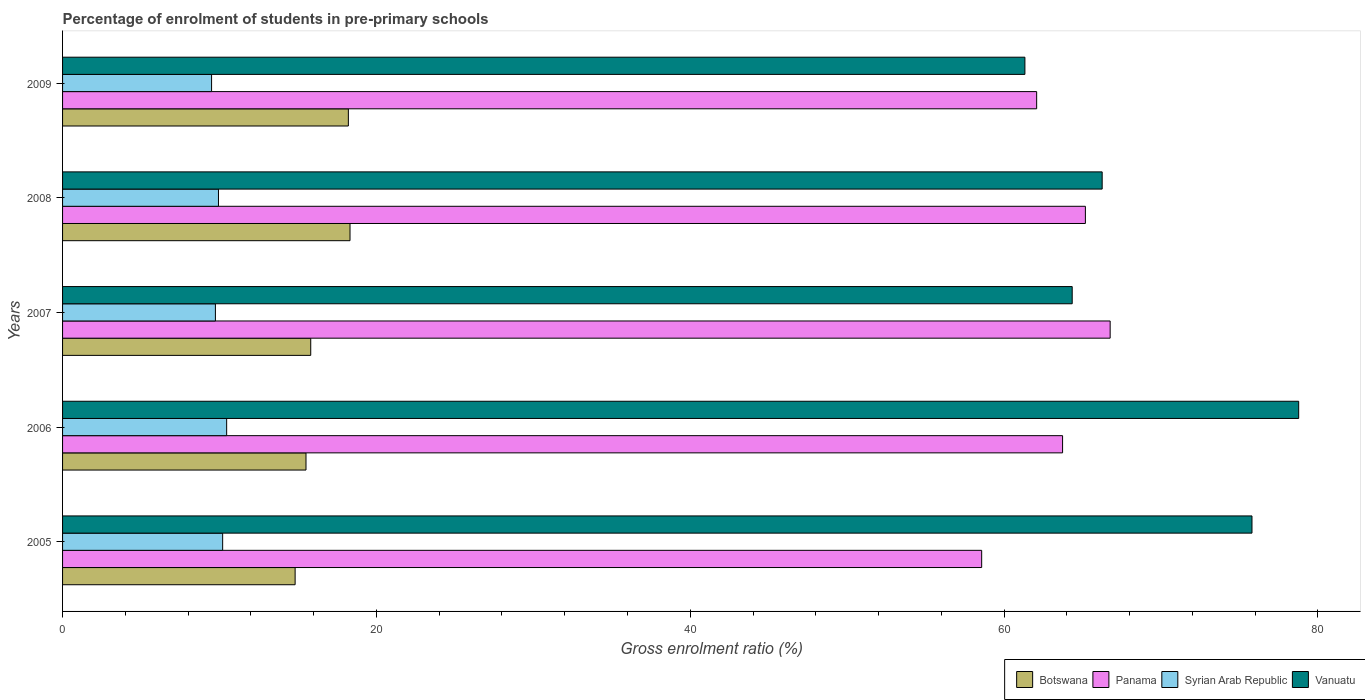How many groups of bars are there?
Make the answer very short. 5. Are the number of bars per tick equal to the number of legend labels?
Provide a succinct answer. Yes. In how many cases, is the number of bars for a given year not equal to the number of legend labels?
Provide a succinct answer. 0. What is the percentage of students enrolled in pre-primary schools in Botswana in 2009?
Offer a very short reply. 18.21. Across all years, what is the maximum percentage of students enrolled in pre-primary schools in Vanuatu?
Ensure brevity in your answer.  78.77. Across all years, what is the minimum percentage of students enrolled in pre-primary schools in Vanuatu?
Your response must be concise. 61.32. In which year was the percentage of students enrolled in pre-primary schools in Panama maximum?
Make the answer very short. 2007. In which year was the percentage of students enrolled in pre-primary schools in Syrian Arab Republic minimum?
Provide a succinct answer. 2009. What is the total percentage of students enrolled in pre-primary schools in Panama in the graph?
Make the answer very short. 316.31. What is the difference between the percentage of students enrolled in pre-primary schools in Botswana in 2007 and that in 2009?
Ensure brevity in your answer.  -2.4. What is the difference between the percentage of students enrolled in pre-primary schools in Botswana in 2005 and the percentage of students enrolled in pre-primary schools in Syrian Arab Republic in 2007?
Provide a short and direct response. 5.08. What is the average percentage of students enrolled in pre-primary schools in Botswana per year?
Ensure brevity in your answer.  16.54. In the year 2006, what is the difference between the percentage of students enrolled in pre-primary schools in Panama and percentage of students enrolled in pre-primary schools in Syrian Arab Republic?
Keep it short and to the point. 53.27. What is the ratio of the percentage of students enrolled in pre-primary schools in Syrian Arab Republic in 2005 to that in 2008?
Your answer should be very brief. 1.03. Is the percentage of students enrolled in pre-primary schools in Panama in 2005 less than that in 2006?
Your answer should be compact. Yes. What is the difference between the highest and the second highest percentage of students enrolled in pre-primary schools in Panama?
Your answer should be compact. 1.58. What is the difference between the highest and the lowest percentage of students enrolled in pre-primary schools in Panama?
Ensure brevity in your answer.  8.19. Is the sum of the percentage of students enrolled in pre-primary schools in Botswana in 2005 and 2008 greater than the maximum percentage of students enrolled in pre-primary schools in Panama across all years?
Offer a very short reply. No. What does the 3rd bar from the top in 2007 represents?
Your response must be concise. Panama. What does the 2nd bar from the bottom in 2009 represents?
Make the answer very short. Panama. Is it the case that in every year, the sum of the percentage of students enrolled in pre-primary schools in Botswana and percentage of students enrolled in pre-primary schools in Vanuatu is greater than the percentage of students enrolled in pre-primary schools in Panama?
Your answer should be very brief. Yes. How many bars are there?
Your response must be concise. 20. Where does the legend appear in the graph?
Provide a succinct answer. Bottom right. What is the title of the graph?
Keep it short and to the point. Percentage of enrolment of students in pre-primary schools. What is the label or title of the X-axis?
Your answer should be very brief. Gross enrolment ratio (%). What is the Gross enrolment ratio (%) of Botswana in 2005?
Ensure brevity in your answer.  14.82. What is the Gross enrolment ratio (%) in Panama in 2005?
Give a very brief answer. 58.57. What is the Gross enrolment ratio (%) in Syrian Arab Republic in 2005?
Offer a very short reply. 10.2. What is the Gross enrolment ratio (%) in Vanuatu in 2005?
Your answer should be compact. 75.8. What is the Gross enrolment ratio (%) of Botswana in 2006?
Your answer should be compact. 15.51. What is the Gross enrolment ratio (%) of Panama in 2006?
Offer a very short reply. 63.73. What is the Gross enrolment ratio (%) of Syrian Arab Republic in 2006?
Provide a short and direct response. 10.46. What is the Gross enrolment ratio (%) in Vanuatu in 2006?
Provide a short and direct response. 78.77. What is the Gross enrolment ratio (%) of Botswana in 2007?
Provide a succinct answer. 15.81. What is the Gross enrolment ratio (%) in Panama in 2007?
Your answer should be compact. 66.76. What is the Gross enrolment ratio (%) in Syrian Arab Republic in 2007?
Give a very brief answer. 9.74. What is the Gross enrolment ratio (%) of Vanuatu in 2007?
Make the answer very short. 64.34. What is the Gross enrolment ratio (%) of Botswana in 2008?
Keep it short and to the point. 18.32. What is the Gross enrolment ratio (%) in Panama in 2008?
Your response must be concise. 65.18. What is the Gross enrolment ratio (%) of Syrian Arab Republic in 2008?
Provide a succinct answer. 9.93. What is the Gross enrolment ratio (%) in Vanuatu in 2008?
Keep it short and to the point. 66.25. What is the Gross enrolment ratio (%) of Botswana in 2009?
Offer a terse response. 18.21. What is the Gross enrolment ratio (%) of Panama in 2009?
Provide a short and direct response. 62.07. What is the Gross enrolment ratio (%) in Syrian Arab Republic in 2009?
Keep it short and to the point. 9.5. What is the Gross enrolment ratio (%) in Vanuatu in 2009?
Provide a short and direct response. 61.32. Across all years, what is the maximum Gross enrolment ratio (%) of Botswana?
Make the answer very short. 18.32. Across all years, what is the maximum Gross enrolment ratio (%) of Panama?
Make the answer very short. 66.76. Across all years, what is the maximum Gross enrolment ratio (%) in Syrian Arab Republic?
Make the answer very short. 10.46. Across all years, what is the maximum Gross enrolment ratio (%) of Vanuatu?
Offer a very short reply. 78.77. Across all years, what is the minimum Gross enrolment ratio (%) in Botswana?
Ensure brevity in your answer.  14.82. Across all years, what is the minimum Gross enrolment ratio (%) in Panama?
Your answer should be compact. 58.57. Across all years, what is the minimum Gross enrolment ratio (%) of Syrian Arab Republic?
Keep it short and to the point. 9.5. Across all years, what is the minimum Gross enrolment ratio (%) of Vanuatu?
Ensure brevity in your answer.  61.32. What is the total Gross enrolment ratio (%) of Botswana in the graph?
Provide a short and direct response. 82.68. What is the total Gross enrolment ratio (%) in Panama in the graph?
Provide a succinct answer. 316.31. What is the total Gross enrolment ratio (%) of Syrian Arab Republic in the graph?
Offer a very short reply. 49.83. What is the total Gross enrolment ratio (%) of Vanuatu in the graph?
Ensure brevity in your answer.  346.48. What is the difference between the Gross enrolment ratio (%) of Botswana in 2005 and that in 2006?
Your answer should be very brief. -0.69. What is the difference between the Gross enrolment ratio (%) in Panama in 2005 and that in 2006?
Ensure brevity in your answer.  -5.16. What is the difference between the Gross enrolment ratio (%) in Syrian Arab Republic in 2005 and that in 2006?
Ensure brevity in your answer.  -0.26. What is the difference between the Gross enrolment ratio (%) in Vanuatu in 2005 and that in 2006?
Keep it short and to the point. -2.98. What is the difference between the Gross enrolment ratio (%) in Botswana in 2005 and that in 2007?
Provide a short and direct response. -0.99. What is the difference between the Gross enrolment ratio (%) of Panama in 2005 and that in 2007?
Offer a very short reply. -8.19. What is the difference between the Gross enrolment ratio (%) in Syrian Arab Republic in 2005 and that in 2007?
Offer a terse response. 0.46. What is the difference between the Gross enrolment ratio (%) in Vanuatu in 2005 and that in 2007?
Your answer should be very brief. 11.46. What is the difference between the Gross enrolment ratio (%) of Botswana in 2005 and that in 2008?
Ensure brevity in your answer.  -3.5. What is the difference between the Gross enrolment ratio (%) of Panama in 2005 and that in 2008?
Offer a terse response. -6.61. What is the difference between the Gross enrolment ratio (%) of Syrian Arab Republic in 2005 and that in 2008?
Make the answer very short. 0.27. What is the difference between the Gross enrolment ratio (%) in Vanuatu in 2005 and that in 2008?
Make the answer very short. 9.55. What is the difference between the Gross enrolment ratio (%) of Botswana in 2005 and that in 2009?
Give a very brief answer. -3.39. What is the difference between the Gross enrolment ratio (%) in Panama in 2005 and that in 2009?
Give a very brief answer. -3.5. What is the difference between the Gross enrolment ratio (%) in Syrian Arab Republic in 2005 and that in 2009?
Offer a very short reply. 0.71. What is the difference between the Gross enrolment ratio (%) in Vanuatu in 2005 and that in 2009?
Give a very brief answer. 14.47. What is the difference between the Gross enrolment ratio (%) in Botswana in 2006 and that in 2007?
Give a very brief answer. -0.3. What is the difference between the Gross enrolment ratio (%) in Panama in 2006 and that in 2007?
Ensure brevity in your answer.  -3.03. What is the difference between the Gross enrolment ratio (%) of Syrian Arab Republic in 2006 and that in 2007?
Give a very brief answer. 0.72. What is the difference between the Gross enrolment ratio (%) in Vanuatu in 2006 and that in 2007?
Your answer should be compact. 14.43. What is the difference between the Gross enrolment ratio (%) of Botswana in 2006 and that in 2008?
Your answer should be compact. -2.81. What is the difference between the Gross enrolment ratio (%) of Panama in 2006 and that in 2008?
Ensure brevity in your answer.  -1.45. What is the difference between the Gross enrolment ratio (%) of Syrian Arab Republic in 2006 and that in 2008?
Give a very brief answer. 0.52. What is the difference between the Gross enrolment ratio (%) in Vanuatu in 2006 and that in 2008?
Offer a very short reply. 12.52. What is the difference between the Gross enrolment ratio (%) in Botswana in 2006 and that in 2009?
Give a very brief answer. -2.7. What is the difference between the Gross enrolment ratio (%) in Panama in 2006 and that in 2009?
Provide a succinct answer. 1.65. What is the difference between the Gross enrolment ratio (%) in Syrian Arab Republic in 2006 and that in 2009?
Your answer should be compact. 0.96. What is the difference between the Gross enrolment ratio (%) of Vanuatu in 2006 and that in 2009?
Provide a short and direct response. 17.45. What is the difference between the Gross enrolment ratio (%) of Botswana in 2007 and that in 2008?
Offer a very short reply. -2.5. What is the difference between the Gross enrolment ratio (%) in Panama in 2007 and that in 2008?
Provide a short and direct response. 1.58. What is the difference between the Gross enrolment ratio (%) in Syrian Arab Republic in 2007 and that in 2008?
Keep it short and to the point. -0.19. What is the difference between the Gross enrolment ratio (%) in Vanuatu in 2007 and that in 2008?
Keep it short and to the point. -1.91. What is the difference between the Gross enrolment ratio (%) of Botswana in 2007 and that in 2009?
Offer a terse response. -2.4. What is the difference between the Gross enrolment ratio (%) of Panama in 2007 and that in 2009?
Offer a very short reply. 4.68. What is the difference between the Gross enrolment ratio (%) in Syrian Arab Republic in 2007 and that in 2009?
Offer a very short reply. 0.24. What is the difference between the Gross enrolment ratio (%) of Vanuatu in 2007 and that in 2009?
Ensure brevity in your answer.  3.01. What is the difference between the Gross enrolment ratio (%) in Botswana in 2008 and that in 2009?
Offer a very short reply. 0.11. What is the difference between the Gross enrolment ratio (%) of Panama in 2008 and that in 2009?
Offer a terse response. 3.11. What is the difference between the Gross enrolment ratio (%) of Syrian Arab Republic in 2008 and that in 2009?
Your answer should be very brief. 0.44. What is the difference between the Gross enrolment ratio (%) in Vanuatu in 2008 and that in 2009?
Ensure brevity in your answer.  4.92. What is the difference between the Gross enrolment ratio (%) in Botswana in 2005 and the Gross enrolment ratio (%) in Panama in 2006?
Provide a short and direct response. -48.91. What is the difference between the Gross enrolment ratio (%) of Botswana in 2005 and the Gross enrolment ratio (%) of Syrian Arab Republic in 2006?
Provide a short and direct response. 4.36. What is the difference between the Gross enrolment ratio (%) of Botswana in 2005 and the Gross enrolment ratio (%) of Vanuatu in 2006?
Your response must be concise. -63.95. What is the difference between the Gross enrolment ratio (%) of Panama in 2005 and the Gross enrolment ratio (%) of Syrian Arab Republic in 2006?
Your response must be concise. 48.11. What is the difference between the Gross enrolment ratio (%) of Panama in 2005 and the Gross enrolment ratio (%) of Vanuatu in 2006?
Give a very brief answer. -20.2. What is the difference between the Gross enrolment ratio (%) of Syrian Arab Republic in 2005 and the Gross enrolment ratio (%) of Vanuatu in 2006?
Make the answer very short. -68.57. What is the difference between the Gross enrolment ratio (%) of Botswana in 2005 and the Gross enrolment ratio (%) of Panama in 2007?
Make the answer very short. -51.94. What is the difference between the Gross enrolment ratio (%) of Botswana in 2005 and the Gross enrolment ratio (%) of Syrian Arab Republic in 2007?
Your answer should be compact. 5.08. What is the difference between the Gross enrolment ratio (%) in Botswana in 2005 and the Gross enrolment ratio (%) in Vanuatu in 2007?
Offer a very short reply. -49.52. What is the difference between the Gross enrolment ratio (%) of Panama in 2005 and the Gross enrolment ratio (%) of Syrian Arab Republic in 2007?
Keep it short and to the point. 48.83. What is the difference between the Gross enrolment ratio (%) in Panama in 2005 and the Gross enrolment ratio (%) in Vanuatu in 2007?
Provide a short and direct response. -5.77. What is the difference between the Gross enrolment ratio (%) in Syrian Arab Republic in 2005 and the Gross enrolment ratio (%) in Vanuatu in 2007?
Your answer should be very brief. -54.14. What is the difference between the Gross enrolment ratio (%) in Botswana in 2005 and the Gross enrolment ratio (%) in Panama in 2008?
Your answer should be very brief. -50.36. What is the difference between the Gross enrolment ratio (%) in Botswana in 2005 and the Gross enrolment ratio (%) in Syrian Arab Republic in 2008?
Your answer should be compact. 4.89. What is the difference between the Gross enrolment ratio (%) of Botswana in 2005 and the Gross enrolment ratio (%) of Vanuatu in 2008?
Your answer should be compact. -51.43. What is the difference between the Gross enrolment ratio (%) in Panama in 2005 and the Gross enrolment ratio (%) in Syrian Arab Republic in 2008?
Offer a terse response. 48.64. What is the difference between the Gross enrolment ratio (%) in Panama in 2005 and the Gross enrolment ratio (%) in Vanuatu in 2008?
Provide a succinct answer. -7.68. What is the difference between the Gross enrolment ratio (%) in Syrian Arab Republic in 2005 and the Gross enrolment ratio (%) in Vanuatu in 2008?
Ensure brevity in your answer.  -56.05. What is the difference between the Gross enrolment ratio (%) of Botswana in 2005 and the Gross enrolment ratio (%) of Panama in 2009?
Offer a very short reply. -47.25. What is the difference between the Gross enrolment ratio (%) of Botswana in 2005 and the Gross enrolment ratio (%) of Syrian Arab Republic in 2009?
Keep it short and to the point. 5.32. What is the difference between the Gross enrolment ratio (%) in Botswana in 2005 and the Gross enrolment ratio (%) in Vanuatu in 2009?
Ensure brevity in your answer.  -46.5. What is the difference between the Gross enrolment ratio (%) in Panama in 2005 and the Gross enrolment ratio (%) in Syrian Arab Republic in 2009?
Keep it short and to the point. 49.07. What is the difference between the Gross enrolment ratio (%) in Panama in 2005 and the Gross enrolment ratio (%) in Vanuatu in 2009?
Your answer should be very brief. -2.76. What is the difference between the Gross enrolment ratio (%) in Syrian Arab Republic in 2005 and the Gross enrolment ratio (%) in Vanuatu in 2009?
Keep it short and to the point. -51.12. What is the difference between the Gross enrolment ratio (%) in Botswana in 2006 and the Gross enrolment ratio (%) in Panama in 2007?
Provide a short and direct response. -51.25. What is the difference between the Gross enrolment ratio (%) of Botswana in 2006 and the Gross enrolment ratio (%) of Syrian Arab Republic in 2007?
Ensure brevity in your answer.  5.77. What is the difference between the Gross enrolment ratio (%) of Botswana in 2006 and the Gross enrolment ratio (%) of Vanuatu in 2007?
Provide a succinct answer. -48.83. What is the difference between the Gross enrolment ratio (%) of Panama in 2006 and the Gross enrolment ratio (%) of Syrian Arab Republic in 2007?
Your response must be concise. 53.99. What is the difference between the Gross enrolment ratio (%) of Panama in 2006 and the Gross enrolment ratio (%) of Vanuatu in 2007?
Provide a short and direct response. -0.61. What is the difference between the Gross enrolment ratio (%) of Syrian Arab Republic in 2006 and the Gross enrolment ratio (%) of Vanuatu in 2007?
Your answer should be very brief. -53.88. What is the difference between the Gross enrolment ratio (%) of Botswana in 2006 and the Gross enrolment ratio (%) of Panama in 2008?
Keep it short and to the point. -49.67. What is the difference between the Gross enrolment ratio (%) in Botswana in 2006 and the Gross enrolment ratio (%) in Syrian Arab Republic in 2008?
Provide a short and direct response. 5.58. What is the difference between the Gross enrolment ratio (%) of Botswana in 2006 and the Gross enrolment ratio (%) of Vanuatu in 2008?
Your answer should be compact. -50.74. What is the difference between the Gross enrolment ratio (%) in Panama in 2006 and the Gross enrolment ratio (%) in Syrian Arab Republic in 2008?
Offer a terse response. 53.79. What is the difference between the Gross enrolment ratio (%) in Panama in 2006 and the Gross enrolment ratio (%) in Vanuatu in 2008?
Offer a very short reply. -2.52. What is the difference between the Gross enrolment ratio (%) of Syrian Arab Republic in 2006 and the Gross enrolment ratio (%) of Vanuatu in 2008?
Make the answer very short. -55.79. What is the difference between the Gross enrolment ratio (%) of Botswana in 2006 and the Gross enrolment ratio (%) of Panama in 2009?
Your answer should be compact. -46.56. What is the difference between the Gross enrolment ratio (%) in Botswana in 2006 and the Gross enrolment ratio (%) in Syrian Arab Republic in 2009?
Provide a short and direct response. 6.02. What is the difference between the Gross enrolment ratio (%) of Botswana in 2006 and the Gross enrolment ratio (%) of Vanuatu in 2009?
Your answer should be compact. -45.81. What is the difference between the Gross enrolment ratio (%) in Panama in 2006 and the Gross enrolment ratio (%) in Syrian Arab Republic in 2009?
Provide a succinct answer. 54.23. What is the difference between the Gross enrolment ratio (%) of Panama in 2006 and the Gross enrolment ratio (%) of Vanuatu in 2009?
Ensure brevity in your answer.  2.4. What is the difference between the Gross enrolment ratio (%) in Syrian Arab Republic in 2006 and the Gross enrolment ratio (%) in Vanuatu in 2009?
Provide a short and direct response. -50.87. What is the difference between the Gross enrolment ratio (%) of Botswana in 2007 and the Gross enrolment ratio (%) of Panama in 2008?
Offer a very short reply. -49.36. What is the difference between the Gross enrolment ratio (%) in Botswana in 2007 and the Gross enrolment ratio (%) in Syrian Arab Republic in 2008?
Make the answer very short. 5.88. What is the difference between the Gross enrolment ratio (%) in Botswana in 2007 and the Gross enrolment ratio (%) in Vanuatu in 2008?
Make the answer very short. -50.43. What is the difference between the Gross enrolment ratio (%) of Panama in 2007 and the Gross enrolment ratio (%) of Syrian Arab Republic in 2008?
Your answer should be compact. 56.82. What is the difference between the Gross enrolment ratio (%) in Panama in 2007 and the Gross enrolment ratio (%) in Vanuatu in 2008?
Make the answer very short. 0.51. What is the difference between the Gross enrolment ratio (%) of Syrian Arab Republic in 2007 and the Gross enrolment ratio (%) of Vanuatu in 2008?
Your answer should be very brief. -56.51. What is the difference between the Gross enrolment ratio (%) of Botswana in 2007 and the Gross enrolment ratio (%) of Panama in 2009?
Offer a very short reply. -46.26. What is the difference between the Gross enrolment ratio (%) in Botswana in 2007 and the Gross enrolment ratio (%) in Syrian Arab Republic in 2009?
Your response must be concise. 6.32. What is the difference between the Gross enrolment ratio (%) of Botswana in 2007 and the Gross enrolment ratio (%) of Vanuatu in 2009?
Ensure brevity in your answer.  -45.51. What is the difference between the Gross enrolment ratio (%) in Panama in 2007 and the Gross enrolment ratio (%) in Syrian Arab Republic in 2009?
Offer a very short reply. 57.26. What is the difference between the Gross enrolment ratio (%) of Panama in 2007 and the Gross enrolment ratio (%) of Vanuatu in 2009?
Ensure brevity in your answer.  5.43. What is the difference between the Gross enrolment ratio (%) in Syrian Arab Republic in 2007 and the Gross enrolment ratio (%) in Vanuatu in 2009?
Ensure brevity in your answer.  -51.59. What is the difference between the Gross enrolment ratio (%) of Botswana in 2008 and the Gross enrolment ratio (%) of Panama in 2009?
Your answer should be very brief. -43.76. What is the difference between the Gross enrolment ratio (%) in Botswana in 2008 and the Gross enrolment ratio (%) in Syrian Arab Republic in 2009?
Your response must be concise. 8.82. What is the difference between the Gross enrolment ratio (%) in Botswana in 2008 and the Gross enrolment ratio (%) in Vanuatu in 2009?
Your answer should be compact. -43.01. What is the difference between the Gross enrolment ratio (%) of Panama in 2008 and the Gross enrolment ratio (%) of Syrian Arab Republic in 2009?
Your response must be concise. 55.68. What is the difference between the Gross enrolment ratio (%) in Panama in 2008 and the Gross enrolment ratio (%) in Vanuatu in 2009?
Provide a succinct answer. 3.85. What is the difference between the Gross enrolment ratio (%) in Syrian Arab Republic in 2008 and the Gross enrolment ratio (%) in Vanuatu in 2009?
Give a very brief answer. -51.39. What is the average Gross enrolment ratio (%) of Botswana per year?
Offer a very short reply. 16.54. What is the average Gross enrolment ratio (%) in Panama per year?
Offer a very short reply. 63.26. What is the average Gross enrolment ratio (%) in Syrian Arab Republic per year?
Offer a terse response. 9.97. What is the average Gross enrolment ratio (%) of Vanuatu per year?
Keep it short and to the point. 69.3. In the year 2005, what is the difference between the Gross enrolment ratio (%) of Botswana and Gross enrolment ratio (%) of Panama?
Make the answer very short. -43.75. In the year 2005, what is the difference between the Gross enrolment ratio (%) of Botswana and Gross enrolment ratio (%) of Syrian Arab Republic?
Keep it short and to the point. 4.62. In the year 2005, what is the difference between the Gross enrolment ratio (%) of Botswana and Gross enrolment ratio (%) of Vanuatu?
Keep it short and to the point. -60.98. In the year 2005, what is the difference between the Gross enrolment ratio (%) in Panama and Gross enrolment ratio (%) in Syrian Arab Republic?
Your response must be concise. 48.37. In the year 2005, what is the difference between the Gross enrolment ratio (%) in Panama and Gross enrolment ratio (%) in Vanuatu?
Make the answer very short. -17.23. In the year 2005, what is the difference between the Gross enrolment ratio (%) of Syrian Arab Republic and Gross enrolment ratio (%) of Vanuatu?
Offer a very short reply. -65.59. In the year 2006, what is the difference between the Gross enrolment ratio (%) of Botswana and Gross enrolment ratio (%) of Panama?
Your answer should be compact. -48.21. In the year 2006, what is the difference between the Gross enrolment ratio (%) of Botswana and Gross enrolment ratio (%) of Syrian Arab Republic?
Ensure brevity in your answer.  5.06. In the year 2006, what is the difference between the Gross enrolment ratio (%) of Botswana and Gross enrolment ratio (%) of Vanuatu?
Your response must be concise. -63.26. In the year 2006, what is the difference between the Gross enrolment ratio (%) in Panama and Gross enrolment ratio (%) in Syrian Arab Republic?
Ensure brevity in your answer.  53.27. In the year 2006, what is the difference between the Gross enrolment ratio (%) in Panama and Gross enrolment ratio (%) in Vanuatu?
Offer a very short reply. -15.05. In the year 2006, what is the difference between the Gross enrolment ratio (%) in Syrian Arab Republic and Gross enrolment ratio (%) in Vanuatu?
Offer a very short reply. -68.31. In the year 2007, what is the difference between the Gross enrolment ratio (%) of Botswana and Gross enrolment ratio (%) of Panama?
Your answer should be compact. -50.94. In the year 2007, what is the difference between the Gross enrolment ratio (%) of Botswana and Gross enrolment ratio (%) of Syrian Arab Republic?
Make the answer very short. 6.08. In the year 2007, what is the difference between the Gross enrolment ratio (%) in Botswana and Gross enrolment ratio (%) in Vanuatu?
Your answer should be very brief. -48.52. In the year 2007, what is the difference between the Gross enrolment ratio (%) of Panama and Gross enrolment ratio (%) of Syrian Arab Republic?
Your answer should be compact. 57.02. In the year 2007, what is the difference between the Gross enrolment ratio (%) of Panama and Gross enrolment ratio (%) of Vanuatu?
Offer a very short reply. 2.42. In the year 2007, what is the difference between the Gross enrolment ratio (%) in Syrian Arab Republic and Gross enrolment ratio (%) in Vanuatu?
Keep it short and to the point. -54.6. In the year 2008, what is the difference between the Gross enrolment ratio (%) of Botswana and Gross enrolment ratio (%) of Panama?
Keep it short and to the point. -46.86. In the year 2008, what is the difference between the Gross enrolment ratio (%) of Botswana and Gross enrolment ratio (%) of Syrian Arab Republic?
Your response must be concise. 8.38. In the year 2008, what is the difference between the Gross enrolment ratio (%) in Botswana and Gross enrolment ratio (%) in Vanuatu?
Provide a succinct answer. -47.93. In the year 2008, what is the difference between the Gross enrolment ratio (%) in Panama and Gross enrolment ratio (%) in Syrian Arab Republic?
Your answer should be very brief. 55.24. In the year 2008, what is the difference between the Gross enrolment ratio (%) of Panama and Gross enrolment ratio (%) of Vanuatu?
Offer a very short reply. -1.07. In the year 2008, what is the difference between the Gross enrolment ratio (%) of Syrian Arab Republic and Gross enrolment ratio (%) of Vanuatu?
Offer a very short reply. -56.31. In the year 2009, what is the difference between the Gross enrolment ratio (%) of Botswana and Gross enrolment ratio (%) of Panama?
Make the answer very short. -43.86. In the year 2009, what is the difference between the Gross enrolment ratio (%) in Botswana and Gross enrolment ratio (%) in Syrian Arab Republic?
Keep it short and to the point. 8.72. In the year 2009, what is the difference between the Gross enrolment ratio (%) of Botswana and Gross enrolment ratio (%) of Vanuatu?
Your answer should be very brief. -43.11. In the year 2009, what is the difference between the Gross enrolment ratio (%) of Panama and Gross enrolment ratio (%) of Syrian Arab Republic?
Make the answer very short. 52.58. In the year 2009, what is the difference between the Gross enrolment ratio (%) in Panama and Gross enrolment ratio (%) in Vanuatu?
Your answer should be very brief. 0.75. In the year 2009, what is the difference between the Gross enrolment ratio (%) of Syrian Arab Republic and Gross enrolment ratio (%) of Vanuatu?
Your answer should be compact. -51.83. What is the ratio of the Gross enrolment ratio (%) of Botswana in 2005 to that in 2006?
Give a very brief answer. 0.96. What is the ratio of the Gross enrolment ratio (%) in Panama in 2005 to that in 2006?
Ensure brevity in your answer.  0.92. What is the ratio of the Gross enrolment ratio (%) of Syrian Arab Republic in 2005 to that in 2006?
Make the answer very short. 0.98. What is the ratio of the Gross enrolment ratio (%) of Vanuatu in 2005 to that in 2006?
Ensure brevity in your answer.  0.96. What is the ratio of the Gross enrolment ratio (%) of Botswana in 2005 to that in 2007?
Your answer should be very brief. 0.94. What is the ratio of the Gross enrolment ratio (%) in Panama in 2005 to that in 2007?
Your answer should be very brief. 0.88. What is the ratio of the Gross enrolment ratio (%) in Syrian Arab Republic in 2005 to that in 2007?
Make the answer very short. 1.05. What is the ratio of the Gross enrolment ratio (%) of Vanuatu in 2005 to that in 2007?
Ensure brevity in your answer.  1.18. What is the ratio of the Gross enrolment ratio (%) of Botswana in 2005 to that in 2008?
Offer a very short reply. 0.81. What is the ratio of the Gross enrolment ratio (%) in Panama in 2005 to that in 2008?
Ensure brevity in your answer.  0.9. What is the ratio of the Gross enrolment ratio (%) in Syrian Arab Republic in 2005 to that in 2008?
Keep it short and to the point. 1.03. What is the ratio of the Gross enrolment ratio (%) of Vanuatu in 2005 to that in 2008?
Keep it short and to the point. 1.14. What is the ratio of the Gross enrolment ratio (%) in Botswana in 2005 to that in 2009?
Keep it short and to the point. 0.81. What is the ratio of the Gross enrolment ratio (%) in Panama in 2005 to that in 2009?
Make the answer very short. 0.94. What is the ratio of the Gross enrolment ratio (%) in Syrian Arab Republic in 2005 to that in 2009?
Make the answer very short. 1.07. What is the ratio of the Gross enrolment ratio (%) of Vanuatu in 2005 to that in 2009?
Offer a very short reply. 1.24. What is the ratio of the Gross enrolment ratio (%) of Botswana in 2006 to that in 2007?
Keep it short and to the point. 0.98. What is the ratio of the Gross enrolment ratio (%) of Panama in 2006 to that in 2007?
Give a very brief answer. 0.95. What is the ratio of the Gross enrolment ratio (%) of Syrian Arab Republic in 2006 to that in 2007?
Offer a very short reply. 1.07. What is the ratio of the Gross enrolment ratio (%) of Vanuatu in 2006 to that in 2007?
Ensure brevity in your answer.  1.22. What is the ratio of the Gross enrolment ratio (%) in Botswana in 2006 to that in 2008?
Give a very brief answer. 0.85. What is the ratio of the Gross enrolment ratio (%) of Panama in 2006 to that in 2008?
Keep it short and to the point. 0.98. What is the ratio of the Gross enrolment ratio (%) in Syrian Arab Republic in 2006 to that in 2008?
Your answer should be very brief. 1.05. What is the ratio of the Gross enrolment ratio (%) in Vanuatu in 2006 to that in 2008?
Your answer should be very brief. 1.19. What is the ratio of the Gross enrolment ratio (%) of Botswana in 2006 to that in 2009?
Your answer should be very brief. 0.85. What is the ratio of the Gross enrolment ratio (%) of Panama in 2006 to that in 2009?
Make the answer very short. 1.03. What is the ratio of the Gross enrolment ratio (%) in Syrian Arab Republic in 2006 to that in 2009?
Provide a short and direct response. 1.1. What is the ratio of the Gross enrolment ratio (%) of Vanuatu in 2006 to that in 2009?
Your answer should be compact. 1.28. What is the ratio of the Gross enrolment ratio (%) of Botswana in 2007 to that in 2008?
Ensure brevity in your answer.  0.86. What is the ratio of the Gross enrolment ratio (%) in Panama in 2007 to that in 2008?
Make the answer very short. 1.02. What is the ratio of the Gross enrolment ratio (%) in Syrian Arab Republic in 2007 to that in 2008?
Give a very brief answer. 0.98. What is the ratio of the Gross enrolment ratio (%) in Vanuatu in 2007 to that in 2008?
Your response must be concise. 0.97. What is the ratio of the Gross enrolment ratio (%) in Botswana in 2007 to that in 2009?
Provide a succinct answer. 0.87. What is the ratio of the Gross enrolment ratio (%) of Panama in 2007 to that in 2009?
Your response must be concise. 1.08. What is the ratio of the Gross enrolment ratio (%) of Syrian Arab Republic in 2007 to that in 2009?
Keep it short and to the point. 1.03. What is the ratio of the Gross enrolment ratio (%) of Vanuatu in 2007 to that in 2009?
Your response must be concise. 1.05. What is the ratio of the Gross enrolment ratio (%) in Botswana in 2008 to that in 2009?
Offer a terse response. 1.01. What is the ratio of the Gross enrolment ratio (%) in Syrian Arab Republic in 2008 to that in 2009?
Offer a very short reply. 1.05. What is the ratio of the Gross enrolment ratio (%) in Vanuatu in 2008 to that in 2009?
Provide a succinct answer. 1.08. What is the difference between the highest and the second highest Gross enrolment ratio (%) of Botswana?
Offer a terse response. 0.11. What is the difference between the highest and the second highest Gross enrolment ratio (%) of Panama?
Offer a very short reply. 1.58. What is the difference between the highest and the second highest Gross enrolment ratio (%) in Syrian Arab Republic?
Give a very brief answer. 0.26. What is the difference between the highest and the second highest Gross enrolment ratio (%) in Vanuatu?
Your answer should be compact. 2.98. What is the difference between the highest and the lowest Gross enrolment ratio (%) in Botswana?
Give a very brief answer. 3.5. What is the difference between the highest and the lowest Gross enrolment ratio (%) in Panama?
Provide a succinct answer. 8.19. What is the difference between the highest and the lowest Gross enrolment ratio (%) in Syrian Arab Republic?
Give a very brief answer. 0.96. What is the difference between the highest and the lowest Gross enrolment ratio (%) of Vanuatu?
Offer a terse response. 17.45. 